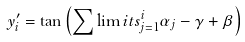<formula> <loc_0><loc_0><loc_500><loc_500>y _ { i } ^ { \prime } = \tan \left ( { \sum \lim i t s _ { j = 1 } ^ { i } { \alpha _ { j } - \gamma + \beta } } \right )</formula> 